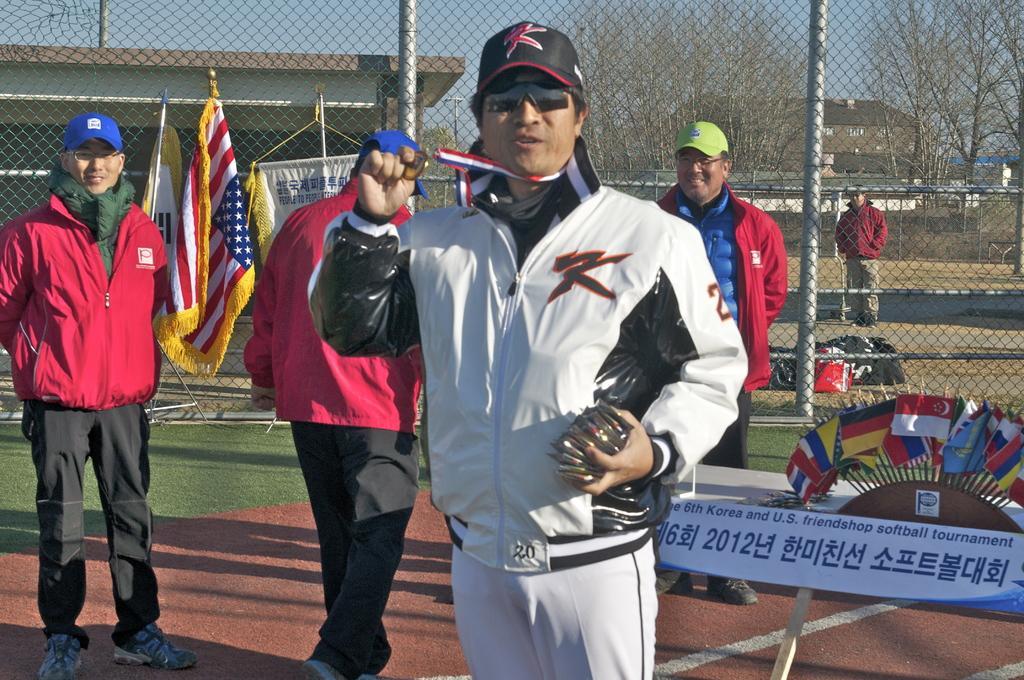Please provide a concise description of this image. In this picture there are group of persons standing and smiling. On the right side there is a board with some text written on it and there are flags and in the center there is metal fence and behind the fence there are flags, there is a person standing, on the ground there are bags and there are dry trees in the background and there are buildings. In the front on the ground there is grass. 